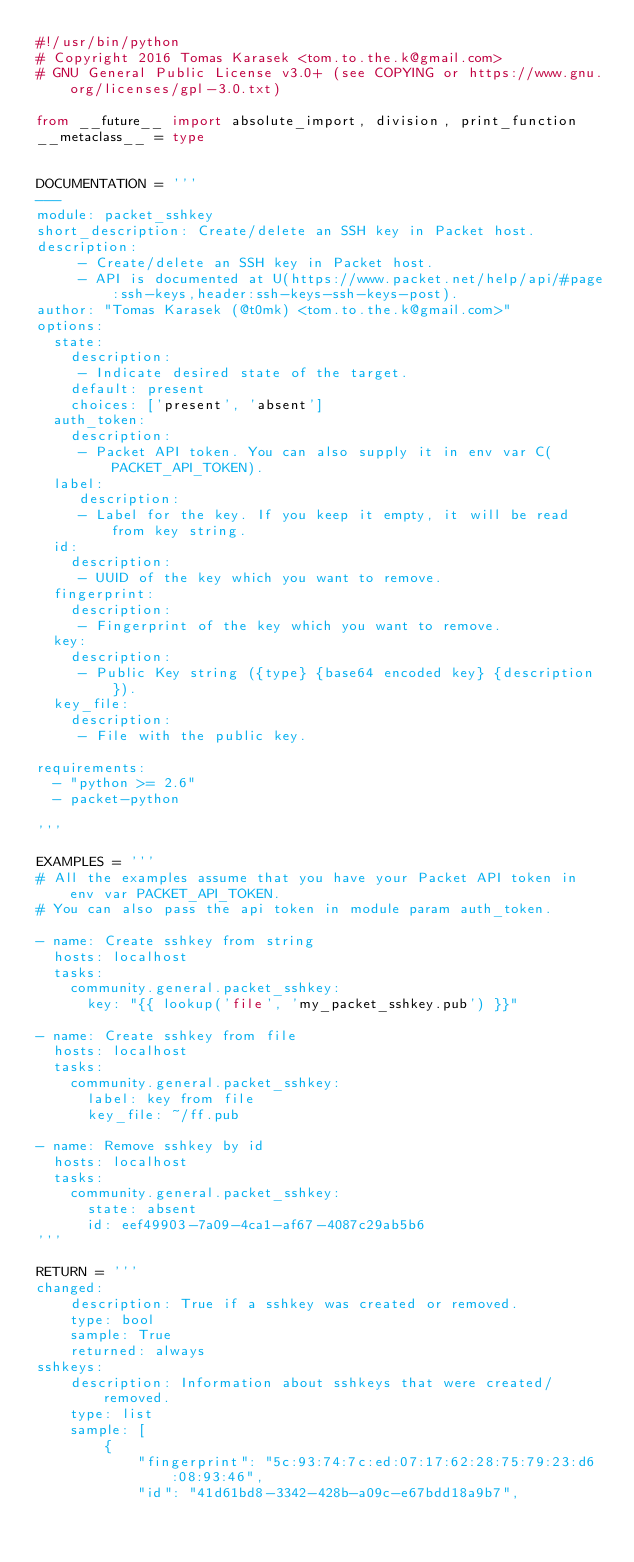Convert code to text. <code><loc_0><loc_0><loc_500><loc_500><_Python_>#!/usr/bin/python
# Copyright 2016 Tomas Karasek <tom.to.the.k@gmail.com>
# GNU General Public License v3.0+ (see COPYING or https://www.gnu.org/licenses/gpl-3.0.txt)

from __future__ import absolute_import, division, print_function
__metaclass__ = type


DOCUMENTATION = '''
---
module: packet_sshkey
short_description: Create/delete an SSH key in Packet host.
description:
     - Create/delete an SSH key in Packet host.
     - API is documented at U(https://www.packet.net/help/api/#page:ssh-keys,header:ssh-keys-ssh-keys-post).
author: "Tomas Karasek (@t0mk) <tom.to.the.k@gmail.com>"
options:
  state:
    description:
     - Indicate desired state of the target.
    default: present
    choices: ['present', 'absent']
  auth_token:
    description:
     - Packet API token. You can also supply it in env var C(PACKET_API_TOKEN).
  label:
     description:
     - Label for the key. If you keep it empty, it will be read from key string.
  id:
    description:
     - UUID of the key which you want to remove.
  fingerprint:
    description:
     - Fingerprint of the key which you want to remove.
  key:
    description:
     - Public Key string ({type} {base64 encoded key} {description}).
  key_file:
    description:
     - File with the public key.

requirements:
  - "python >= 2.6"
  - packet-python

'''

EXAMPLES = '''
# All the examples assume that you have your Packet API token in env var PACKET_API_TOKEN.
# You can also pass the api token in module param auth_token.

- name: Create sshkey from string
  hosts: localhost
  tasks:
    community.general.packet_sshkey:
      key: "{{ lookup('file', 'my_packet_sshkey.pub') }}"

- name: Create sshkey from file
  hosts: localhost
  tasks:
    community.general.packet_sshkey:
      label: key from file
      key_file: ~/ff.pub

- name: Remove sshkey by id
  hosts: localhost
  tasks:
    community.general.packet_sshkey:
      state: absent
      id: eef49903-7a09-4ca1-af67-4087c29ab5b6
'''

RETURN = '''
changed:
    description: True if a sshkey was created or removed.
    type: bool
    sample: True
    returned: always
sshkeys:
    description: Information about sshkeys that were created/removed.
    type: list
    sample: [
        {
            "fingerprint": "5c:93:74:7c:ed:07:17:62:28:75:79:23:d6:08:93:46",
            "id": "41d61bd8-3342-428b-a09c-e67bdd18a9b7",</code> 